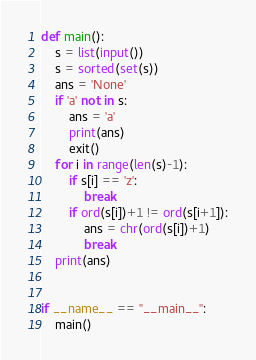<code> <loc_0><loc_0><loc_500><loc_500><_Python_>def main():
    s = list(input())
    s = sorted(set(s))
    ans = 'None'
    if 'a' not in s:
        ans = 'a'
        print(ans)
        exit()
    for i in range(len(s)-1):
        if s[i] == 'z':
            break
        if ord(s[i])+1 != ord(s[i+1]):
            ans = chr(ord(s[i])+1)
            break
    print(ans)


if __name__ == "__main__":
    main()
</code> 